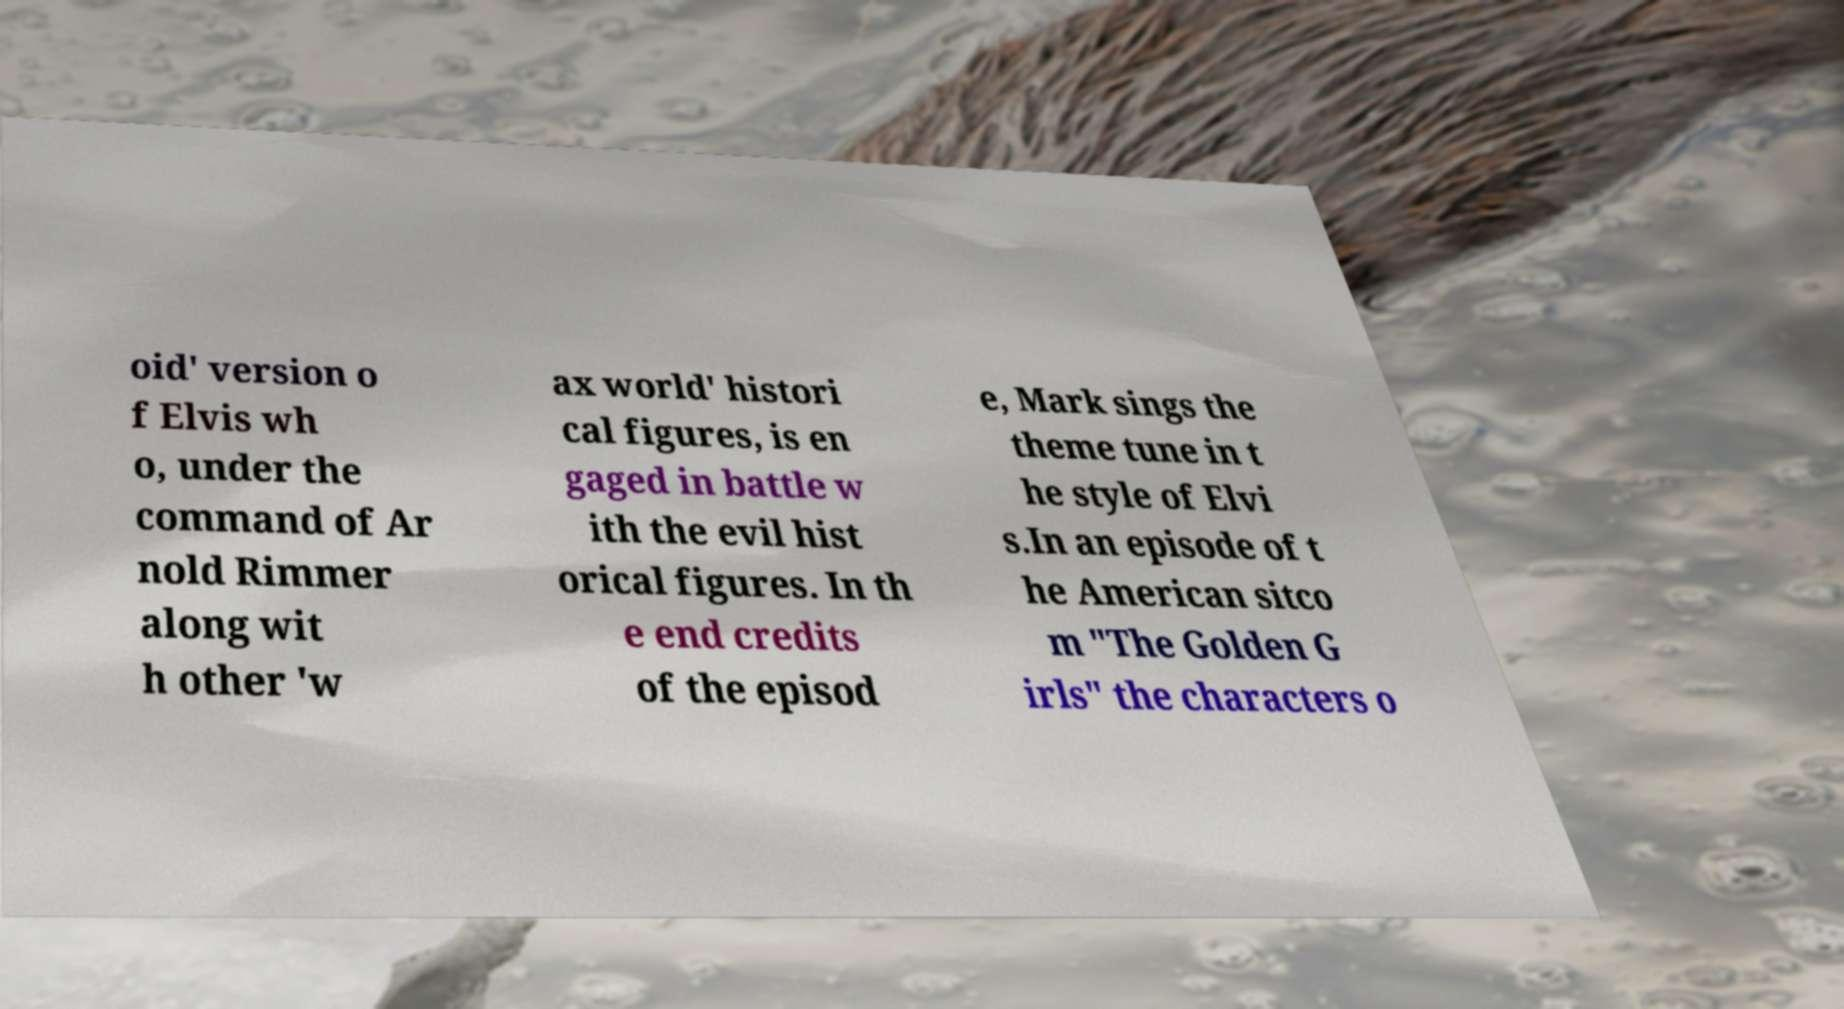Please read and relay the text visible in this image. What does it say? oid' version o f Elvis wh o, under the command of Ar nold Rimmer along wit h other 'w ax world' histori cal figures, is en gaged in battle w ith the evil hist orical figures. In th e end credits of the episod e, Mark sings the theme tune in t he style of Elvi s.In an episode of t he American sitco m "The Golden G irls" the characters o 